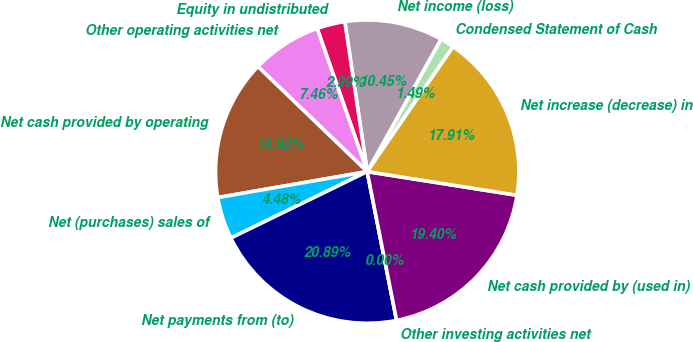<chart> <loc_0><loc_0><loc_500><loc_500><pie_chart><fcel>Condensed Statement of Cash<fcel>Net income (loss)<fcel>Equity in undistributed<fcel>Other operating activities net<fcel>Net cash provided by operating<fcel>Net (purchases) sales of<fcel>Net payments from (to)<fcel>Other investing activities net<fcel>Net cash provided by (used in)<fcel>Net increase (decrease) in<nl><fcel>1.49%<fcel>10.45%<fcel>2.99%<fcel>7.46%<fcel>14.92%<fcel>4.48%<fcel>20.89%<fcel>0.0%<fcel>19.4%<fcel>17.91%<nl></chart> 